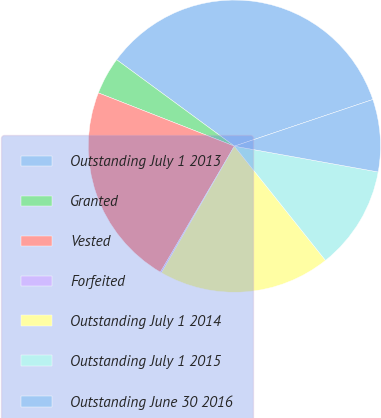Convert chart to OTSL. <chart><loc_0><loc_0><loc_500><loc_500><pie_chart><fcel>Outstanding July 1 2013<fcel>Granted<fcel>Vested<fcel>Forfeited<fcel>Outstanding July 1 2014<fcel>Outstanding July 1 2015<fcel>Outstanding June 30 2016<nl><fcel>34.75%<fcel>4.14%<fcel>22.49%<fcel>0.14%<fcel>19.03%<fcel>11.46%<fcel>8.0%<nl></chart> 